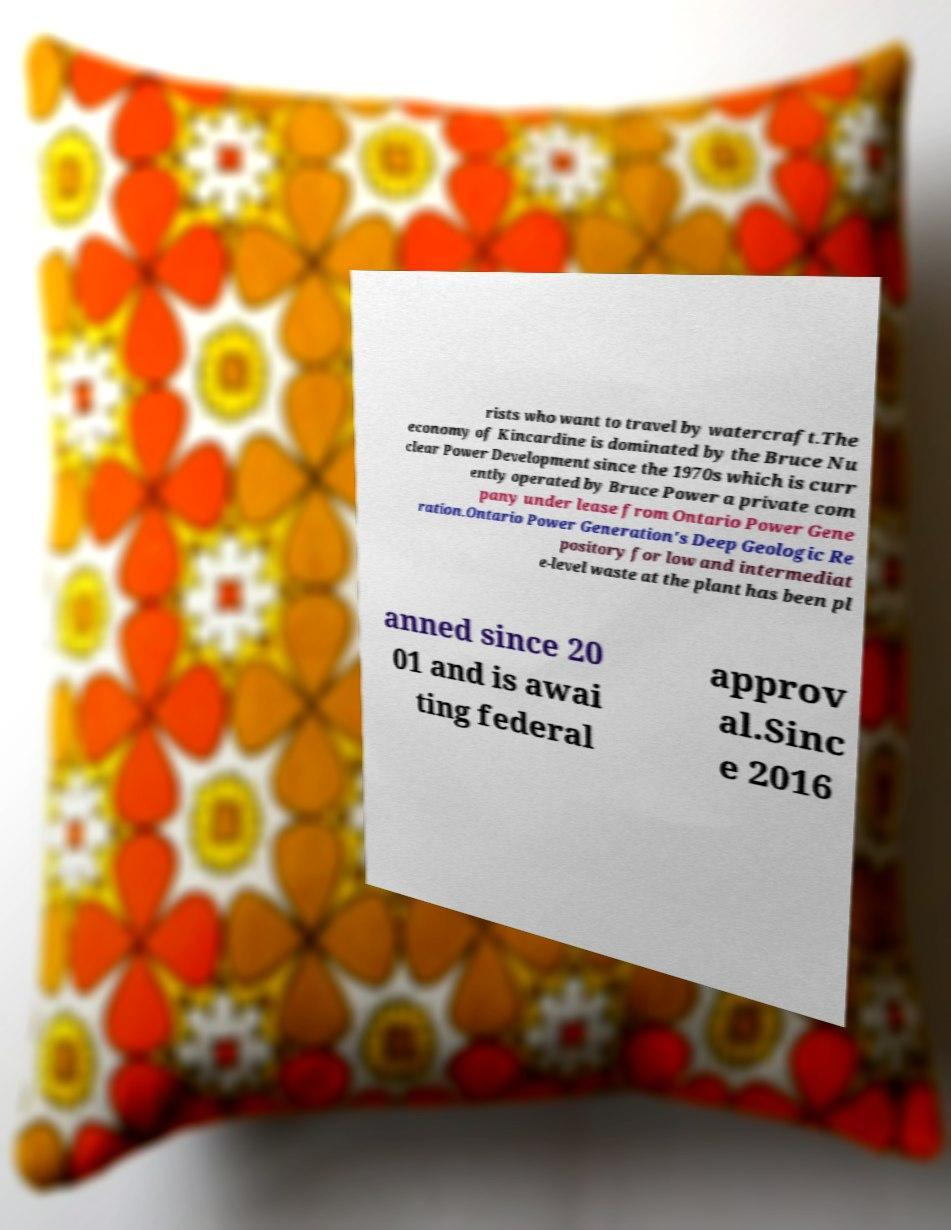For documentation purposes, I need the text within this image transcribed. Could you provide that? rists who want to travel by watercraft.The economy of Kincardine is dominated by the Bruce Nu clear Power Development since the 1970s which is curr ently operated by Bruce Power a private com pany under lease from Ontario Power Gene ration.Ontario Power Generation's Deep Geologic Re pository for low and intermediat e-level waste at the plant has been pl anned since 20 01 and is awai ting federal approv al.Sinc e 2016 